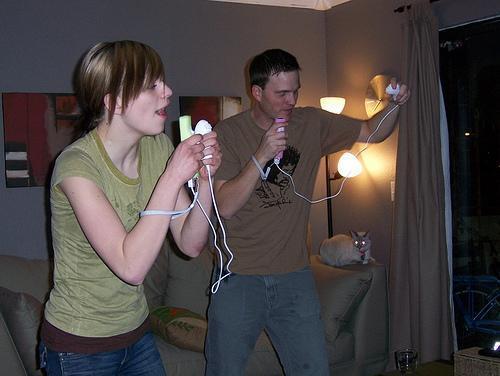How many people can you see?
Give a very brief answer. 2. How many zebras are facing right in the picture?
Give a very brief answer. 0. 